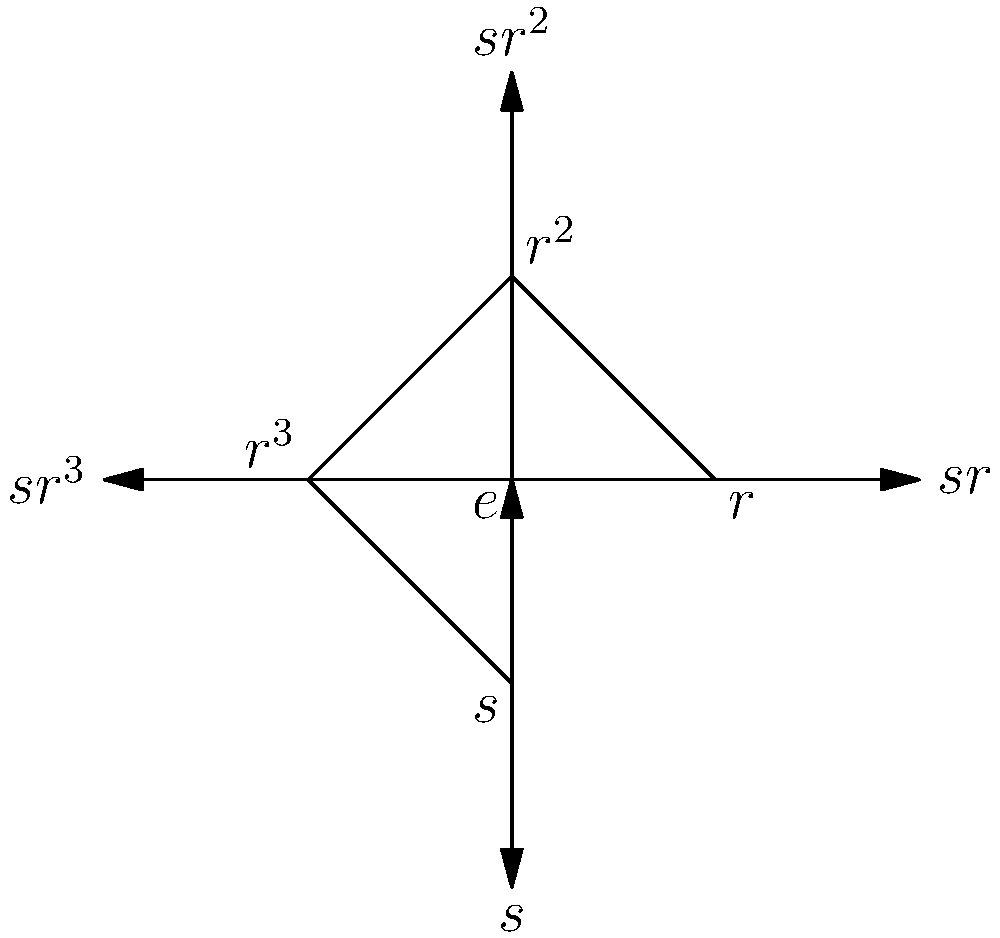В контексте разработки VR/AR приложений, рассмотрите Cayley граф диэдральной группы $D_4$, представленный выше. Какое минимальное количество генераторов необходимо для создания этой группы, и как это может повлиять на оптимизацию алгоритмов симметрии в виртуальном пространстве? Для ответа на этот вопрос, рассмотрим следующие шаги:

1) Диэдральная группа $D_4$ представляет симметрии правильного четырехугольника (квадрата).

2) На Cayley графе видны два типа ребер:
   - Круговые ребра, соединяющие элементы $e$, $r$, $r^2$, $r^3$
   - Радиальные ребра, соединяющие элементы с их отражениями

3) Круговые ребра представляют вращения на 90°, генерируемые элементом $r$.

4) Радиальные ребра представляют отражения, генерируемые элементом $s$.

5) Заметим, что все элементы группы могут быть получены комбинацией $r$ и $s$.

6) Таким образом, минимальное количество генераторов равно 2: $r$ (вращение) и $s$ (отражение).

7) В контексте VR/AR это означает, что для реализации всех симметрий квадратного объекта достаточно запрограммировать два базовых преобразования:
   - Вращение на 90°
   - Отражение относительно оси

8) Это позволяет оптимизировать алгоритмы симметрии, сократив количество базовых операций до минимума, что особенно важно для производительности VR/AR приложений.
Answer: 2 генератора ($r$ и $s$) 